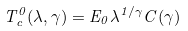<formula> <loc_0><loc_0><loc_500><loc_500>T _ { c } ^ { 0 } ( \lambda , \gamma ) = E _ { 0 } \lambda ^ { 1 / \gamma } C ( \gamma )</formula> 